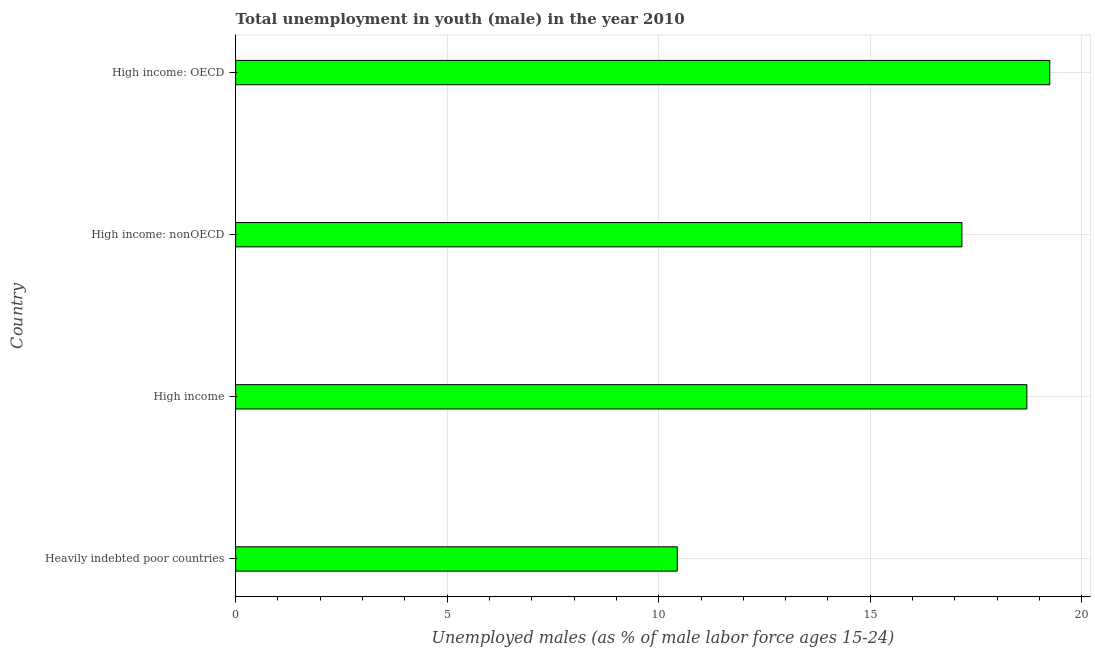What is the title of the graph?
Provide a succinct answer. Total unemployment in youth (male) in the year 2010. What is the label or title of the X-axis?
Your answer should be compact. Unemployed males (as % of male labor force ages 15-24). What is the unemployed male youth population in High income: nonOECD?
Provide a succinct answer. 17.17. Across all countries, what is the maximum unemployed male youth population?
Provide a succinct answer. 19.24. Across all countries, what is the minimum unemployed male youth population?
Your response must be concise. 10.44. In which country was the unemployed male youth population maximum?
Your answer should be compact. High income: OECD. In which country was the unemployed male youth population minimum?
Ensure brevity in your answer.  Heavily indebted poor countries. What is the sum of the unemployed male youth population?
Ensure brevity in your answer.  65.55. What is the difference between the unemployed male youth population in Heavily indebted poor countries and High income?
Offer a very short reply. -8.26. What is the average unemployed male youth population per country?
Ensure brevity in your answer.  16.39. What is the median unemployed male youth population?
Provide a succinct answer. 17.93. In how many countries, is the unemployed male youth population greater than 18 %?
Offer a very short reply. 2. What is the ratio of the unemployed male youth population in High income to that in High income: nonOECD?
Ensure brevity in your answer.  1.09. What is the difference between the highest and the second highest unemployed male youth population?
Ensure brevity in your answer.  0.54. Is the sum of the unemployed male youth population in Heavily indebted poor countries and High income: nonOECD greater than the maximum unemployed male youth population across all countries?
Your answer should be compact. Yes. In how many countries, is the unemployed male youth population greater than the average unemployed male youth population taken over all countries?
Offer a terse response. 3. Are all the bars in the graph horizontal?
Provide a short and direct response. Yes. What is the difference between two consecutive major ticks on the X-axis?
Keep it short and to the point. 5. What is the Unemployed males (as % of male labor force ages 15-24) of Heavily indebted poor countries?
Provide a succinct answer. 10.44. What is the Unemployed males (as % of male labor force ages 15-24) in High income?
Ensure brevity in your answer.  18.7. What is the Unemployed males (as % of male labor force ages 15-24) of High income: nonOECD?
Provide a short and direct response. 17.17. What is the Unemployed males (as % of male labor force ages 15-24) of High income: OECD?
Offer a terse response. 19.24. What is the difference between the Unemployed males (as % of male labor force ages 15-24) in Heavily indebted poor countries and High income?
Offer a terse response. -8.26. What is the difference between the Unemployed males (as % of male labor force ages 15-24) in Heavily indebted poor countries and High income: nonOECD?
Provide a succinct answer. -6.73. What is the difference between the Unemployed males (as % of male labor force ages 15-24) in Heavily indebted poor countries and High income: OECD?
Your answer should be very brief. -8.8. What is the difference between the Unemployed males (as % of male labor force ages 15-24) in High income and High income: nonOECD?
Provide a short and direct response. 1.53. What is the difference between the Unemployed males (as % of male labor force ages 15-24) in High income and High income: OECD?
Your answer should be compact. -0.54. What is the difference between the Unemployed males (as % of male labor force ages 15-24) in High income: nonOECD and High income: OECD?
Ensure brevity in your answer.  -2.08. What is the ratio of the Unemployed males (as % of male labor force ages 15-24) in Heavily indebted poor countries to that in High income?
Offer a terse response. 0.56. What is the ratio of the Unemployed males (as % of male labor force ages 15-24) in Heavily indebted poor countries to that in High income: nonOECD?
Provide a succinct answer. 0.61. What is the ratio of the Unemployed males (as % of male labor force ages 15-24) in Heavily indebted poor countries to that in High income: OECD?
Provide a succinct answer. 0.54. What is the ratio of the Unemployed males (as % of male labor force ages 15-24) in High income to that in High income: nonOECD?
Offer a very short reply. 1.09. What is the ratio of the Unemployed males (as % of male labor force ages 15-24) in High income to that in High income: OECD?
Ensure brevity in your answer.  0.97. What is the ratio of the Unemployed males (as % of male labor force ages 15-24) in High income: nonOECD to that in High income: OECD?
Offer a terse response. 0.89. 